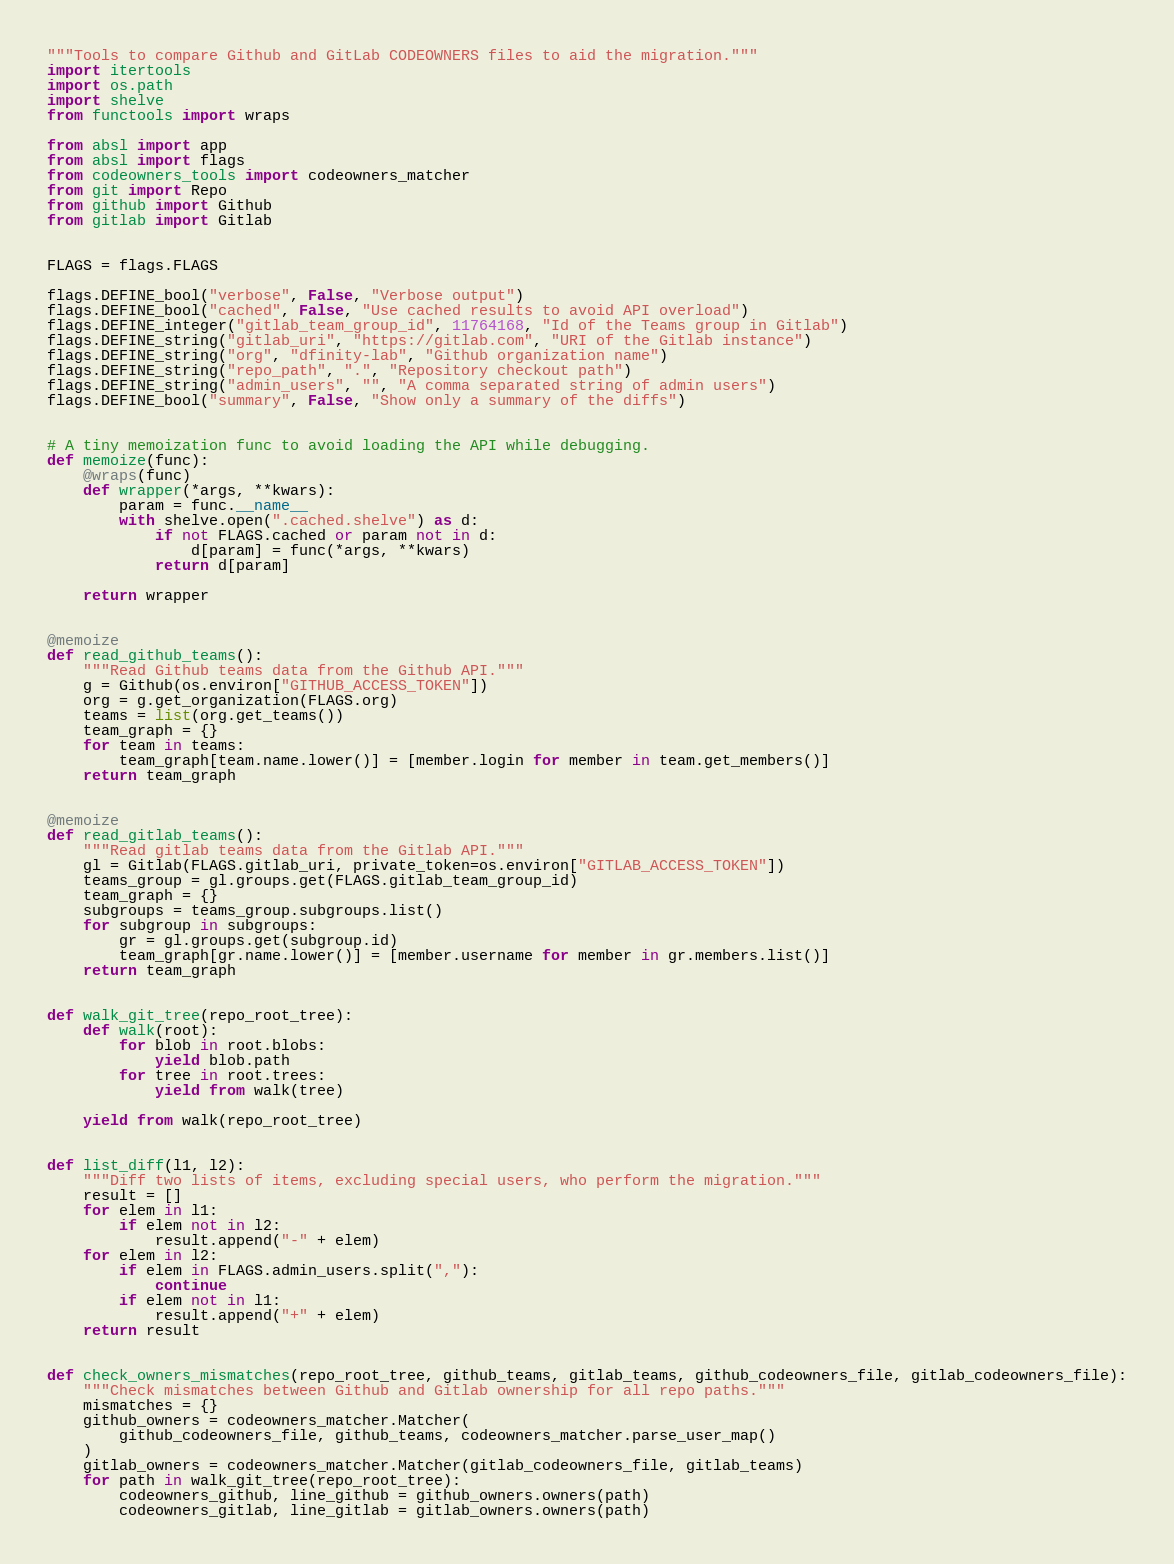Convert code to text. <code><loc_0><loc_0><loc_500><loc_500><_Python_>"""Tools to compare Github and GitLab CODEOWNERS files to aid the migration."""
import itertools
import os.path
import shelve
from functools import wraps

from absl import app
from absl import flags
from codeowners_tools import codeowners_matcher
from git import Repo
from github import Github
from gitlab import Gitlab


FLAGS = flags.FLAGS

flags.DEFINE_bool("verbose", False, "Verbose output")
flags.DEFINE_bool("cached", False, "Use cached results to avoid API overload")
flags.DEFINE_integer("gitlab_team_group_id", 11764168, "Id of the Teams group in Gitlab")
flags.DEFINE_string("gitlab_uri", "https://gitlab.com", "URI of the Gitlab instance")
flags.DEFINE_string("org", "dfinity-lab", "Github organization name")
flags.DEFINE_string("repo_path", ".", "Repository checkout path")
flags.DEFINE_string("admin_users", "", "A comma separated string of admin users")
flags.DEFINE_bool("summary", False, "Show only a summary of the diffs")


# A tiny memoization func to avoid loading the API while debugging.
def memoize(func):
    @wraps(func)
    def wrapper(*args, **kwars):
        param = func.__name__
        with shelve.open(".cached.shelve") as d:
            if not FLAGS.cached or param not in d:
                d[param] = func(*args, **kwars)
            return d[param]

    return wrapper


@memoize
def read_github_teams():
    """Read Github teams data from the Github API."""
    g = Github(os.environ["GITHUB_ACCESS_TOKEN"])
    org = g.get_organization(FLAGS.org)
    teams = list(org.get_teams())
    team_graph = {}
    for team in teams:
        team_graph[team.name.lower()] = [member.login for member in team.get_members()]
    return team_graph


@memoize
def read_gitlab_teams():
    """Read gitlab teams data from the Gitlab API."""
    gl = Gitlab(FLAGS.gitlab_uri, private_token=os.environ["GITLAB_ACCESS_TOKEN"])
    teams_group = gl.groups.get(FLAGS.gitlab_team_group_id)
    team_graph = {}
    subgroups = teams_group.subgroups.list()
    for subgroup in subgroups:
        gr = gl.groups.get(subgroup.id)
        team_graph[gr.name.lower()] = [member.username for member in gr.members.list()]
    return team_graph


def walk_git_tree(repo_root_tree):
    def walk(root):
        for blob in root.blobs:
            yield blob.path
        for tree in root.trees:
            yield from walk(tree)

    yield from walk(repo_root_tree)


def list_diff(l1, l2):
    """Diff two lists of items, excluding special users, who perform the migration."""
    result = []
    for elem in l1:
        if elem not in l2:
            result.append("-" + elem)
    for elem in l2:
        if elem in FLAGS.admin_users.split(","):
            continue
        if elem not in l1:
            result.append("+" + elem)
    return result


def check_owners_mismatches(repo_root_tree, github_teams, gitlab_teams, github_codeowners_file, gitlab_codeowners_file):
    """Check mismatches between Github and Gitlab ownership for all repo paths."""
    mismatches = {}
    github_owners = codeowners_matcher.Matcher(
        github_codeowners_file, github_teams, codeowners_matcher.parse_user_map()
    )
    gitlab_owners = codeowners_matcher.Matcher(gitlab_codeowners_file, gitlab_teams)
    for path in walk_git_tree(repo_root_tree):
        codeowners_github, line_github = github_owners.owners(path)
        codeowners_gitlab, line_gitlab = gitlab_owners.owners(path)</code> 